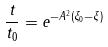Convert formula to latex. <formula><loc_0><loc_0><loc_500><loc_500>\frac { t } { t _ { 0 } } = e ^ { - A ^ { 2 } ( \xi _ { 0 } - \xi ) }</formula> 